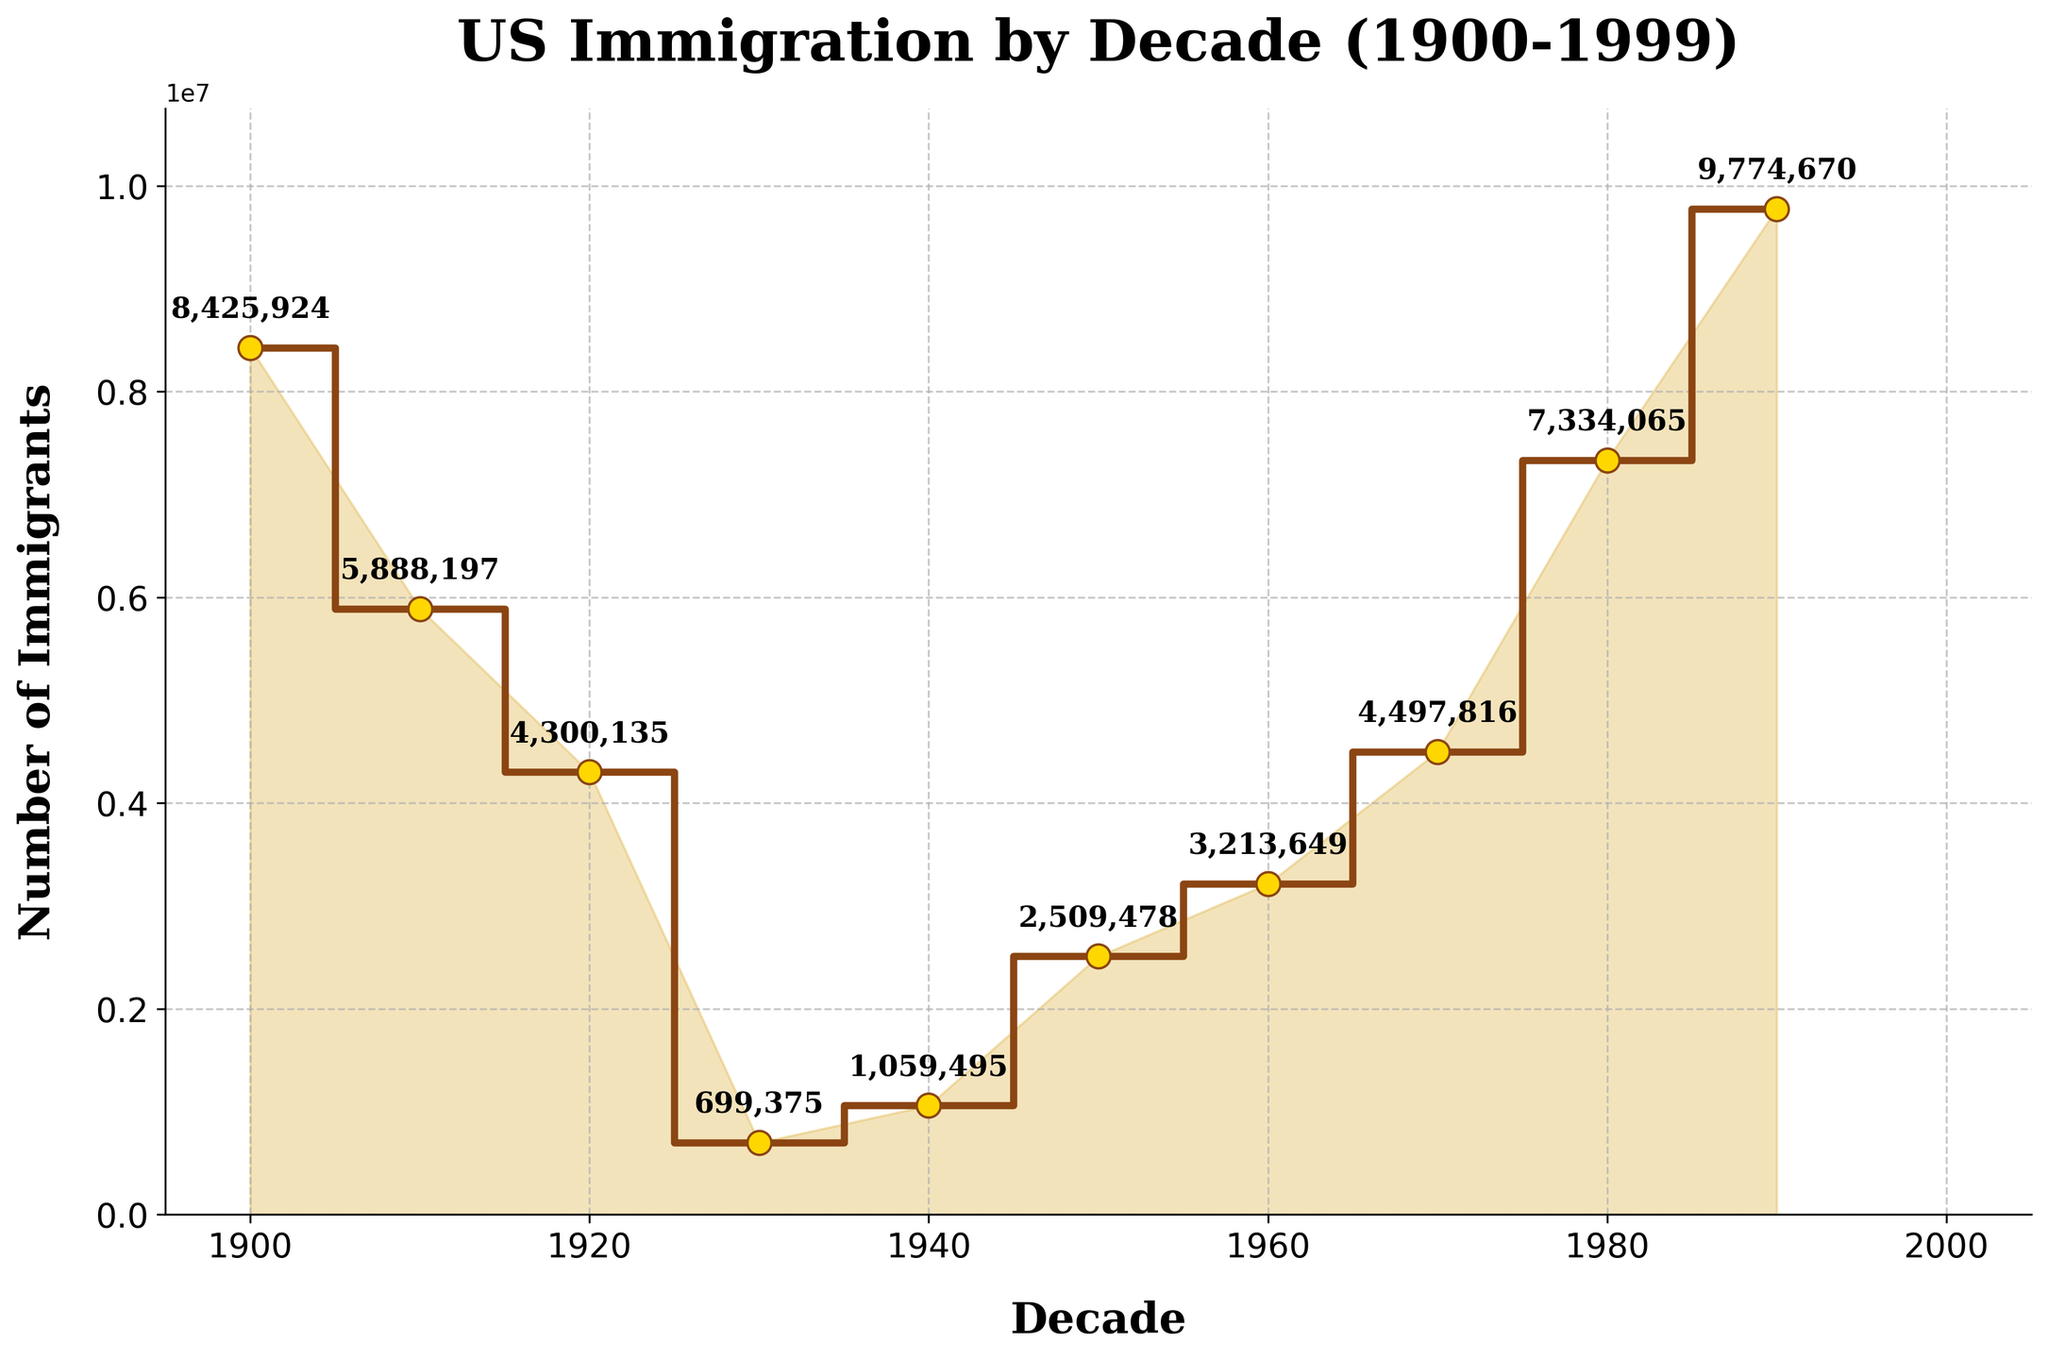what is the number of immigrants in the 1900s? Locate the point corresponding to the 1900s on the x-axis and read the y-coordinate value. The number of immigrants in the 1900s is 8,425,924.
Answer: 8,425,924 which decade saw the lowest number of immigrants? Identify the lowest point on the y-axis and connect it to the corresponding x-axis value. The 1930s saw the lowest number of immigrants with 699,375.
Answer: 1930s what is the overall trend in the number of immigrants from 1900 to 1999? Observe the general pattern of the stair plot. The overall trend shows a decline from the 1900s to 1930s, followed by periods of increase and fluctuation, ending with the highest number of immigrants in the 1990s.
Answer: decline, then increase in which decade did the number of immigrants first rise above 4 million after the 1930s? Look for the first point after the 1930s where the value exceeds 4 million on the y-axis. The 1970s saw the number of immigrants rise above 4 million.
Answer: 1970s how does the number of immigrants in the 1950s compare to the 1920s? Compare the y-axis values for the 1950s and the 1920s. The 1950s (2,509,478 immigrants) had fewer immigrants than the 1920s (4,300,135 immigrants).
Answer: less which decade experienced the greatest increase in the number of immigrants compared to the previous decade? Calculate the difference in the number of immigrants between consecutive decades and identify the largest value. The 1940s to 1950s saw the greatest increase of 1,451,983 immigrants.
Answer: 1940s to 1950s what is the sum of the number of immigrants in the 1970s and 1980s? Add the number of immigrants in the 1970s and 1980s. The sum is 4,497,816 (1970s) + 7,334,065 (1980s) = 11,831,881.
Answer: 11,831,881 what is the difference in the number of immigrants between the 1900s and the 1930s? Subtract the number of immigrants in the 1930s from the number in the 1900s. The difference is 8,425,924 (1900s) - 699,375 (1930s) = 7,726,549.
Answer: 7,726,549 how does the pattern of the number of immigrants change before and after the 1930s? Compare the shape of the stair plot before and after the 1930s. Before the 1930s, there is a decline; after the 1930s, the plot shows an overall increase in the number of immigrants.
Answer: decline, then increase which two consecutive decades had the smallest change in the number of immigrants? Look for two consecutive points on the stair plot with the smallest vertical distance. The 1940s to 1950s had the smallest change with a difference of 945,983 immigrants.
Answer: 1940s to 1950s 